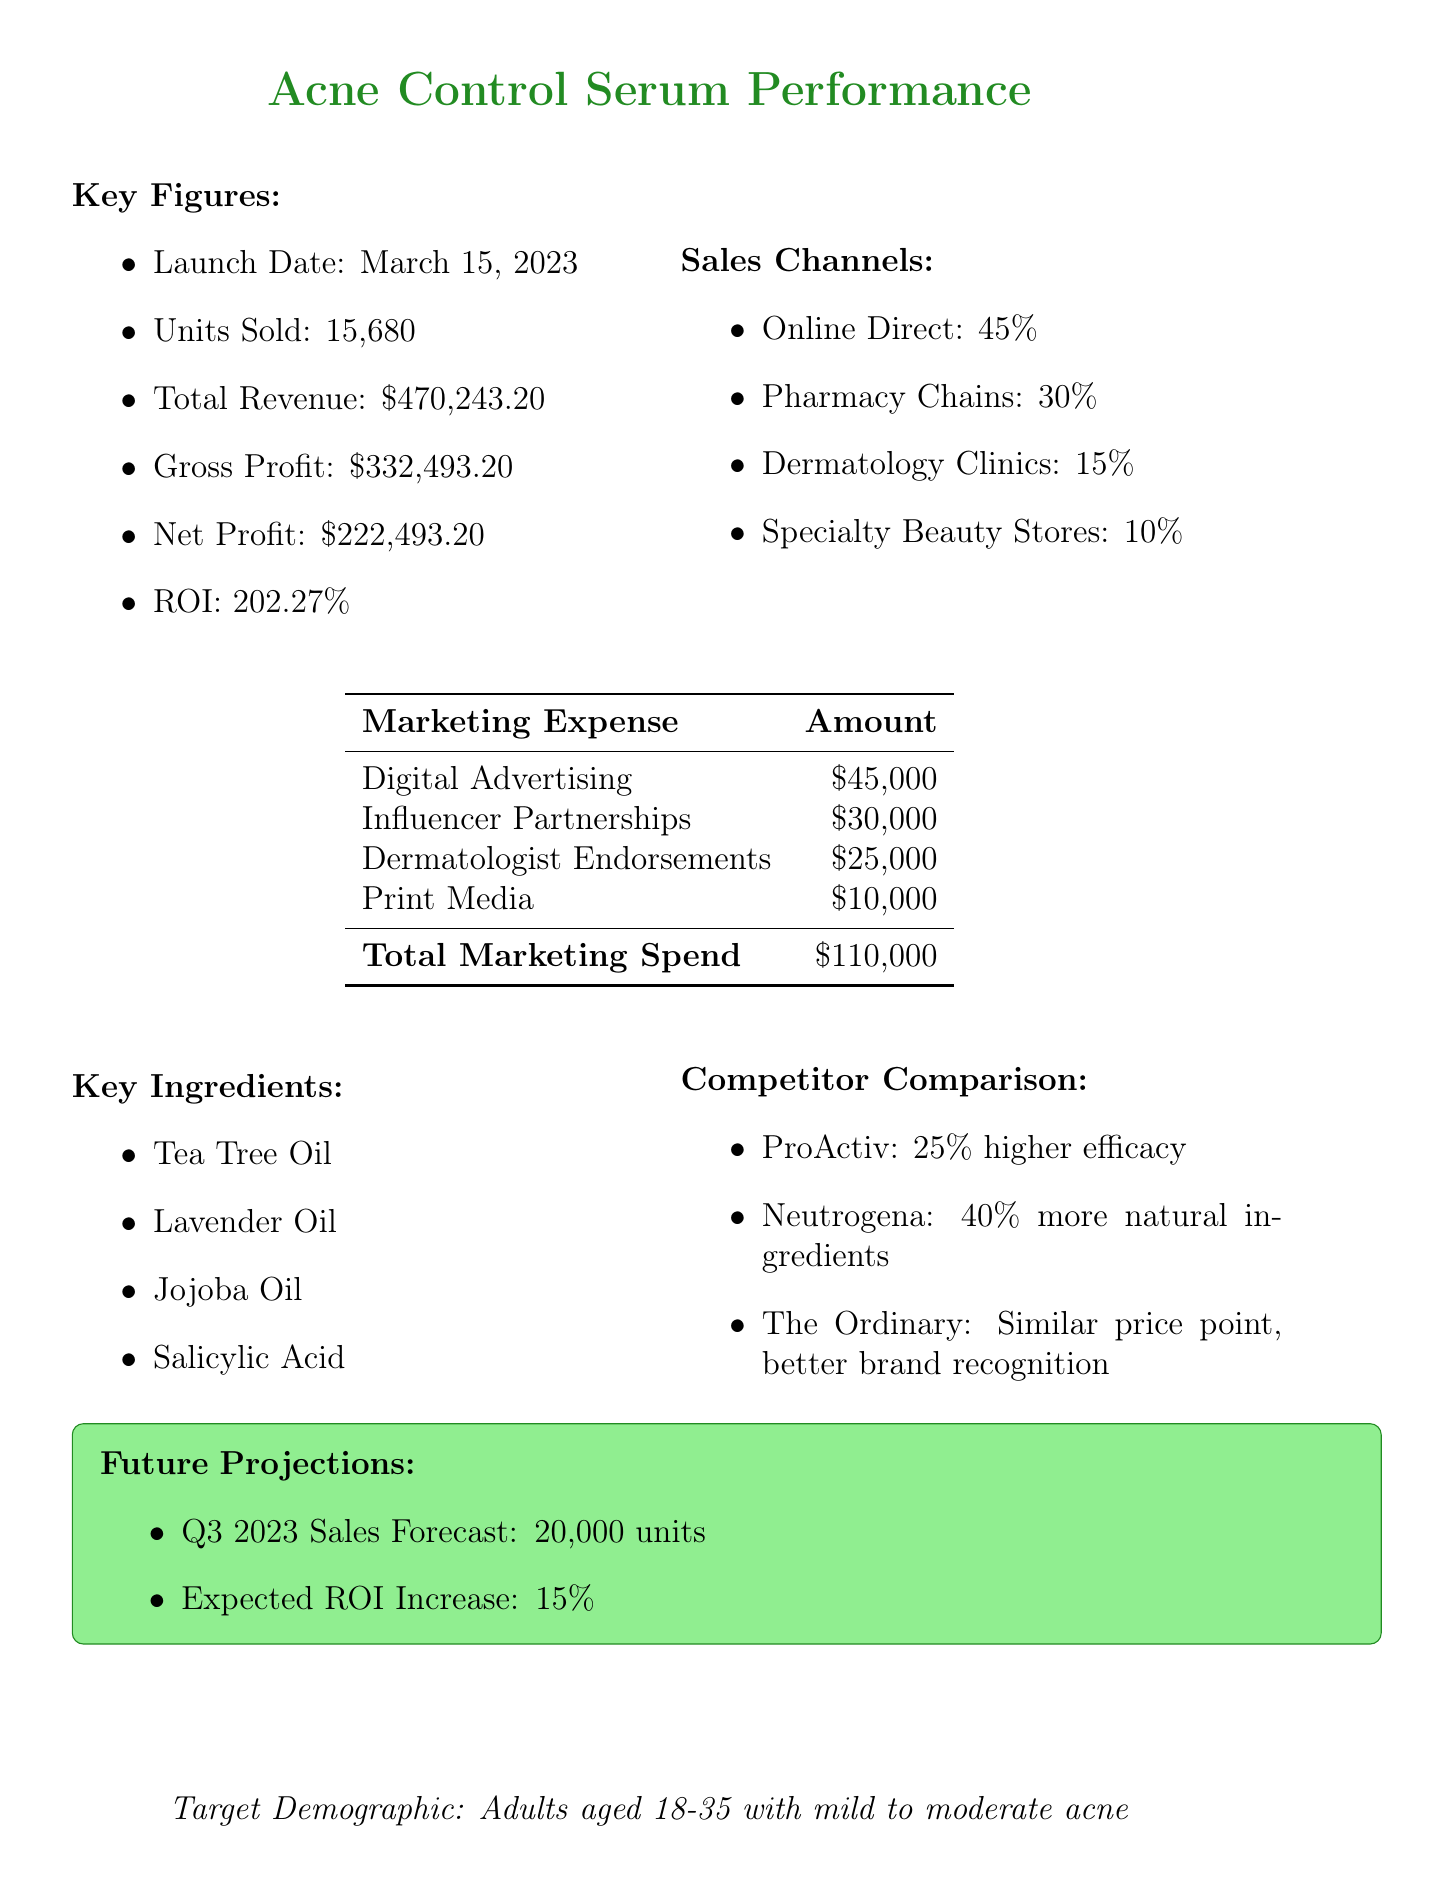what is the product name? The product name is clearly stated in the document as "ClearSkin Botanicals Acne Control Serum."
Answer: ClearSkin Botanicals Acne Control Serum when was the product launched? The launch date is specified in the document as March 15, 2023.
Answer: March 15, 2023 how many units were sold? The document mentions that 15,680 units were sold during the reporting period.
Answer: 15,680 what was the total marketing spend? The total marketing spend is calculated by summing all the marketing expenses listed, which equals $110,000.
Answer: $110,000 what is the return on investment? The return on investment is explicitly stated as 202.27%.
Answer: 202.27% which ingredient is not mentioned as a key ingredient? The key ingredients are listed clearly, and "Benzoyl Peroxide" is not included in that list.
Answer: Benzoyl Peroxide what is the expected ROI increase for Q3 2023? The document forecasts a 15% expected increase in ROI for Q3 2023.
Answer: 15% what percentage of sales came from online direct channels? The percentage of sales through online direct channels is given as 45% in the sales channels section.
Answer: 45% which competitor has a higher efficacy than ClearSkin Botanicals? The document states that ProActiv has 25% higher efficacy.
Answer: ProActiv 